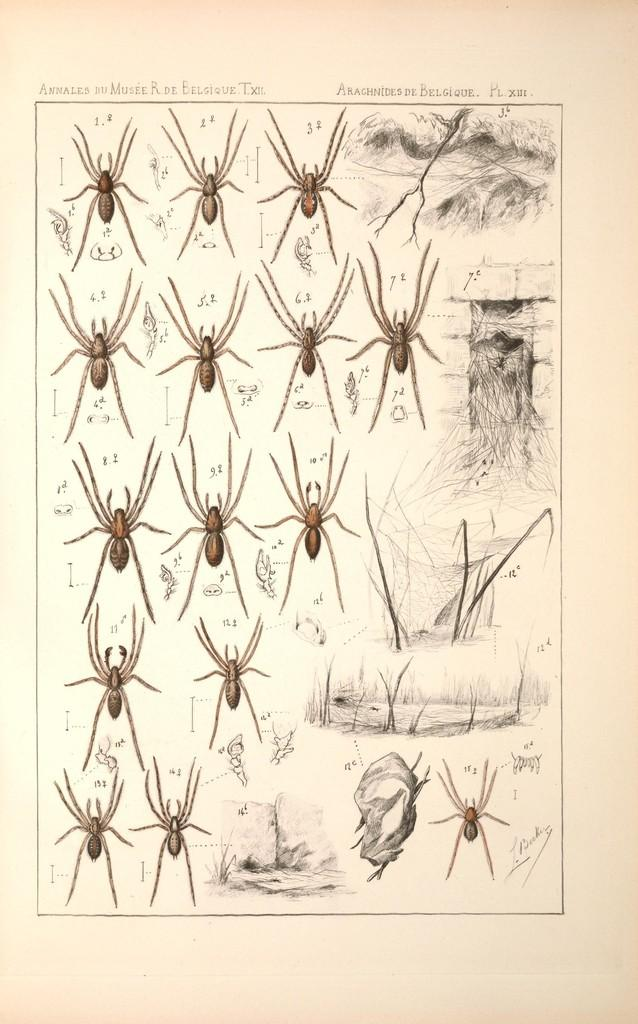What type of creatures can be seen in the image? There are insects in the image. What color are the insects? The insects are brown in color. What is the color of the background in the image? The background of the image is white. What type of harbor can be seen in the image? There is no harbor present in the image; it features insects on a white background. What arithmetic problem can be solved using the insects in the image? There is no arithmetic problem present in the image, as it only features insects and a white background. 